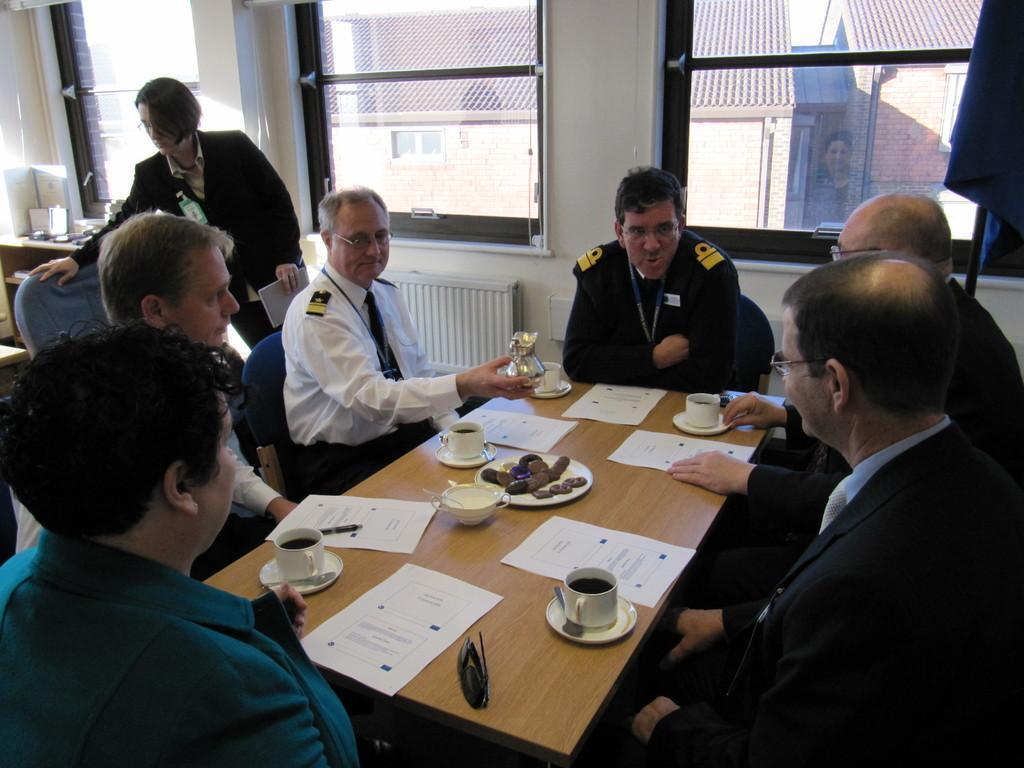How would you summarize this image in a sentence or two? In this picture there are some group of people sitting on the chairs in front of the tables on which some things are placed and behind there is a woman and two Windows. 